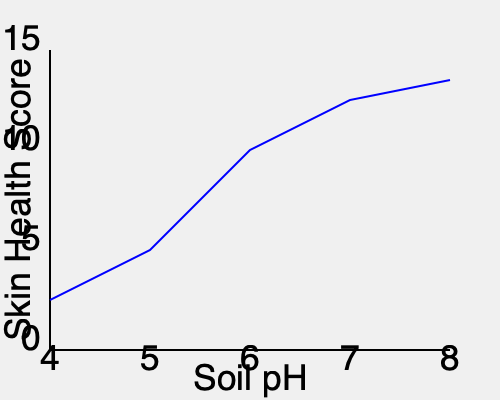Based on the graph showing the relationship between soil pH and skin health score in burrowing animals, what is the approximate optimal soil pH range for maintaining the best skin health in these animals? To determine the optimal soil pH range for the best skin health in burrowing animals, we need to analyze the graph step-by-step:

1. The x-axis represents soil pH, ranging from 4 to 8.
2. The y-axis represents the skin health score, with higher scores indicating better skin health.
3. The blue line shows the relationship between soil pH and skin health score.

4. Observing the trend:
   - At pH 4, the skin health score is relatively low (around 3).
   - As pH increases, the skin health score improves rapidly.
   - The line begins to level off around pH 7.
   - The highest point on the curve appears to be between pH 7 and 8.

5. Identifying the optimal range:
   - The steepest improvement occurs between pH 5 and 7.
   - The peak of the curve is around pH 7.5.
   - After pH 7.5, the improvement in skin health score is minimal.

6. Conclusion:
   The optimal soil pH range for maintaining the best skin health in burrowing animals appears to be between 7 and 8, with the peak around 7.5.

This range corresponds to slightly alkaline soil conditions, which seem to promote the best skin health in these animals.
Answer: pH 7-8 